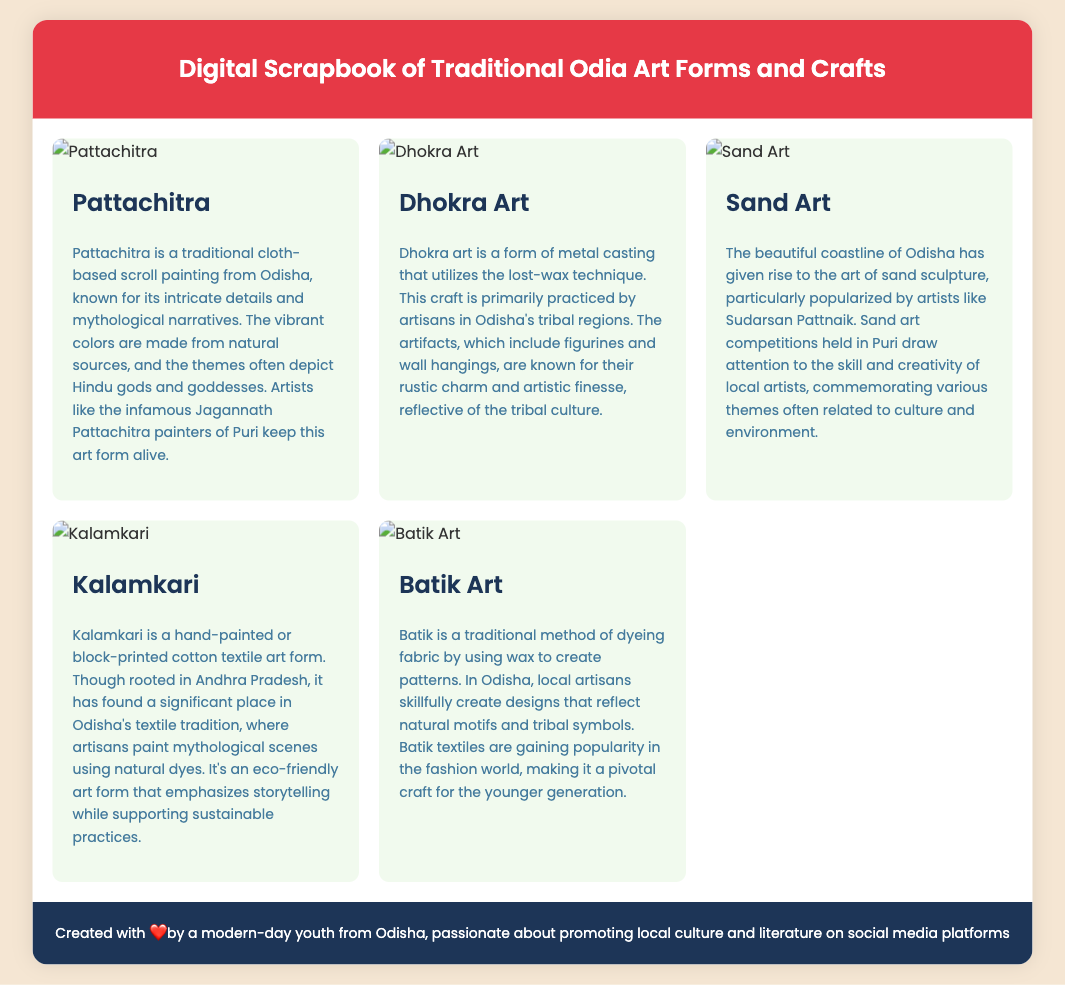What is the title of the scrapbook? The title is mentioned in the header of the document.
Answer: Digital Scrapbook of Traditional Odia Art Forms and Crafts How many art forms are showcased in the scrapbook? There are five art forms listed, each represented by distinct sections in the scrapbook.
Answer: Five Who is a famous artist associated with Sand Art in Odisha? The document mentions a prominent artist known for this craft.
Answer: Sudarsan Pattnaik What traditional painting form is known for mythological narratives? This question refers to the specific art form highlighted in the content.
Answer: Pattachitra Which art form uses the lost-wax technique? The document specifies the craft associated with this technique in its description.
Answer: Dhokra Art What does Kalamkari emphasize in its creation? The emphasis of Kalamkari is detailed in the description about its storytelling aspect.
Answer: Storytelling What is the background color of the scrapbook's body? The color is specified in the styling section for visual reference.
Answer: #f5e6d3 What type of items does Batik Art often feature? The document gives insight into the designs typically created through this art form.
Answer: Natural motifs and tribal symbols 